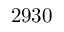<formula> <loc_0><loc_0><loc_500><loc_500>2 9 3 0</formula> 